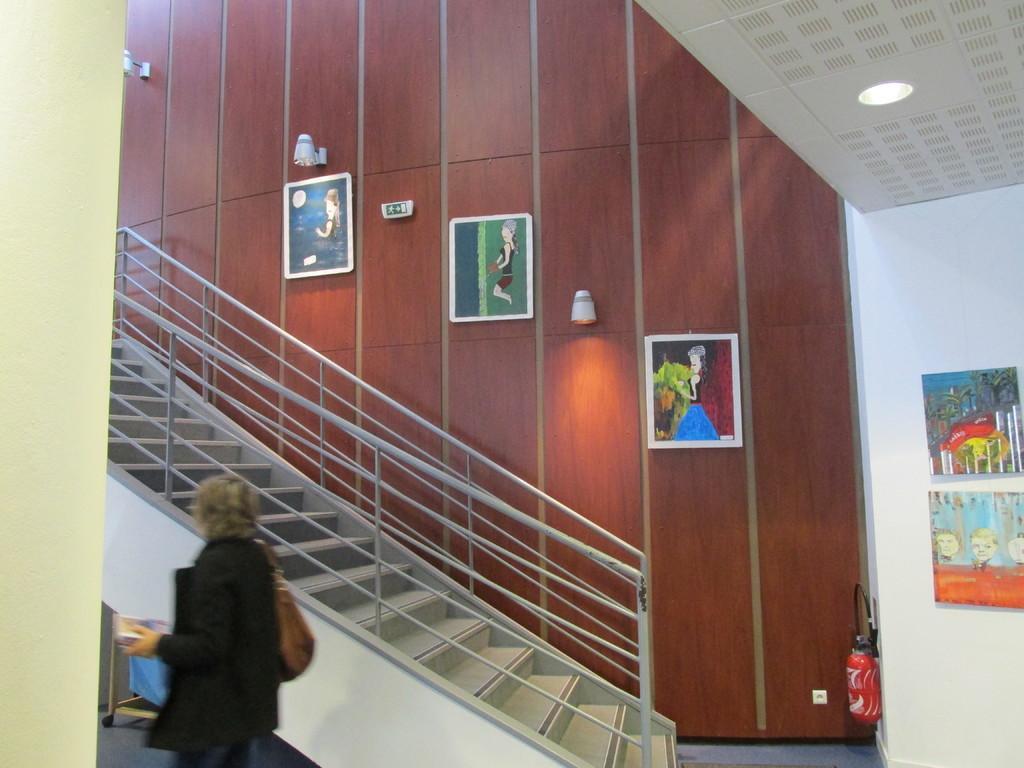Please provide a concise description of this image. In this image I can see a person wearing black colored dress and brown color bag is standing and holding an object in her hand. I can see few stairs, the railing, the white and brown colored walls, few frames, few lights and a fire extinguisher. 